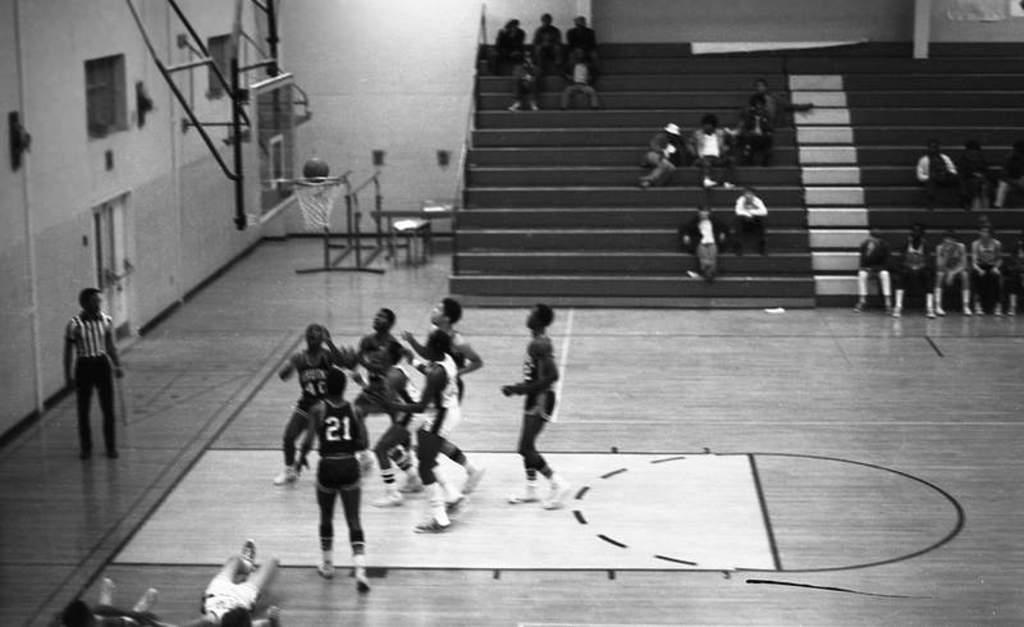Provide a one-sentence caption for the provided image. A basketball going on in a gym with one player have 21 on his jersey. 